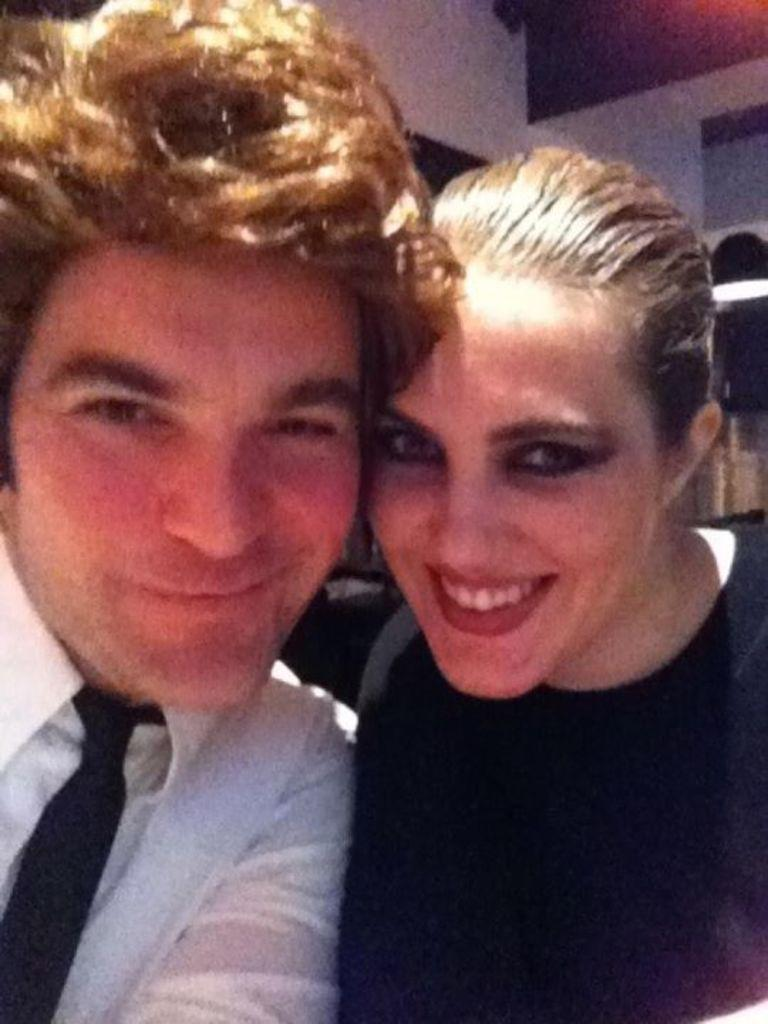How many people are present in the image? There is a man and a woman in the image. What can be seen in the background of the image? There is a wall, light, and other objects in the background of the image. Can you describe the setting of the image? The image features a man and a woman in front of a wall with light and other objects in the background. What type of boat is visible in the image? There is no boat present in the image. What unit of measurement is used to describe the size of the woman in the image? The provided facts do not include any information about the size of the woman or any unit of measurement. 